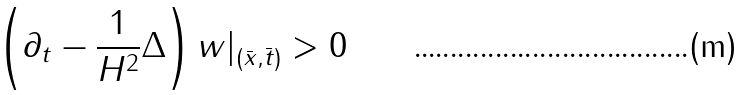<formula> <loc_0><loc_0><loc_500><loc_500>\left ( \partial _ { t } - \frac { 1 } { H ^ { 2 } } \Delta \right ) w | _ { ( \bar { x } , \bar { t } ) } > 0</formula> 